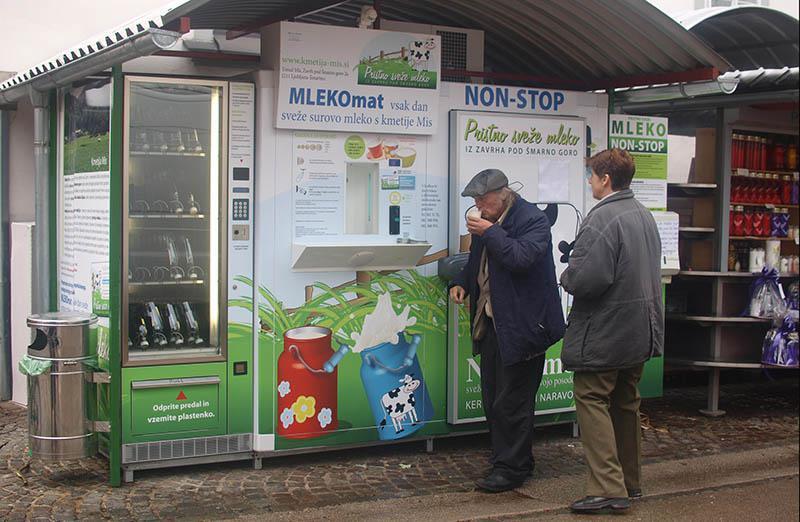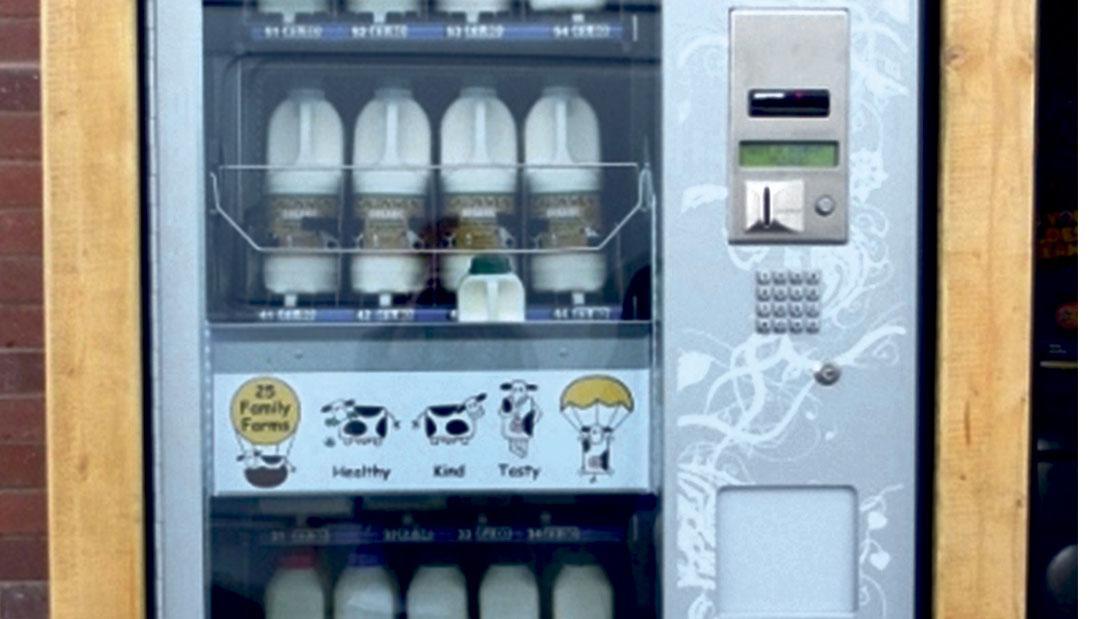The first image is the image on the left, the second image is the image on the right. For the images shown, is this caption "A vending machine has distinctive black and white markings." true? Answer yes or no. No. 